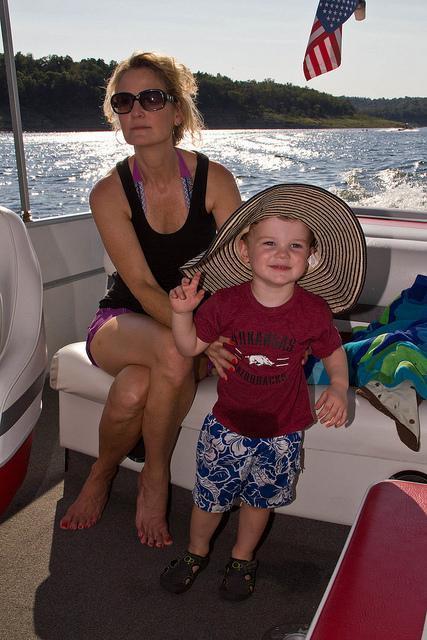How many people can be seen?
Give a very brief answer. 2. How many cars are parked in this picture?
Give a very brief answer. 0. 